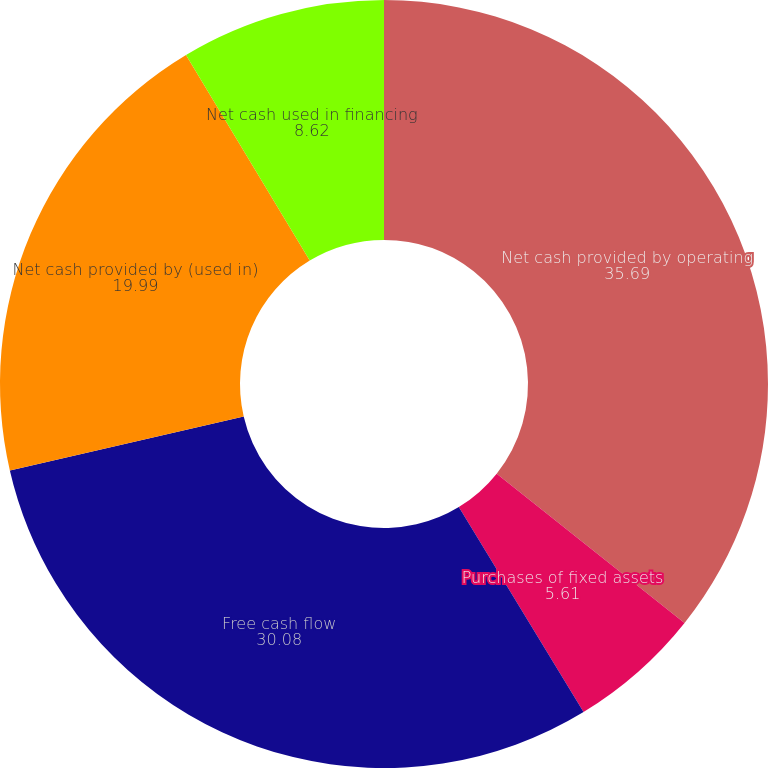<chart> <loc_0><loc_0><loc_500><loc_500><pie_chart><fcel>Net cash provided by operating<fcel>Purchases of fixed assets<fcel>Free cash flow<fcel>Net cash provided by (used in)<fcel>Net cash used in financing<nl><fcel>35.69%<fcel>5.61%<fcel>30.08%<fcel>19.99%<fcel>8.62%<nl></chart> 